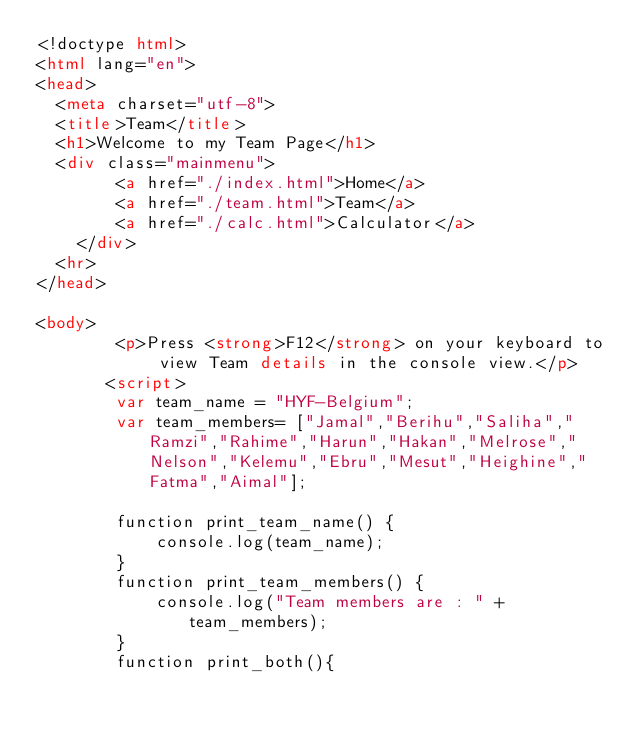<code> <loc_0><loc_0><loc_500><loc_500><_HTML_><!doctype html>
<html lang="en">
<head>
  <meta charset="utf-8">
  <title>Team</title>
  <h1>Welcome to my Team Page</h1>
  <div class="mainmenu">
        <a href="./index.html">Home</a> 
        <a href="./team.html">Team</a> 
        <a href="./calc.html">Calculator</a> 
    </div>
  <hr>
</head>

<body>
        <p>Press <strong>F12</strong> on your keyboard to view Team details in the console view.</p>
       <script>
        var team_name = "HYF-Belgium";
        var team_members= ["Jamal","Berihu","Saliha","Ramzi","Rahime","Harun","Hakan","Melrose","Nelson","Kelemu","Ebru","Mesut","Heighine","Fatma","Aimal"];
        
        function print_team_name() {
            console.log(team_name);
        }
        function print_team_members() {
            console.log("Team members are : " + team_members);
        }
        function print_both(){</code> 